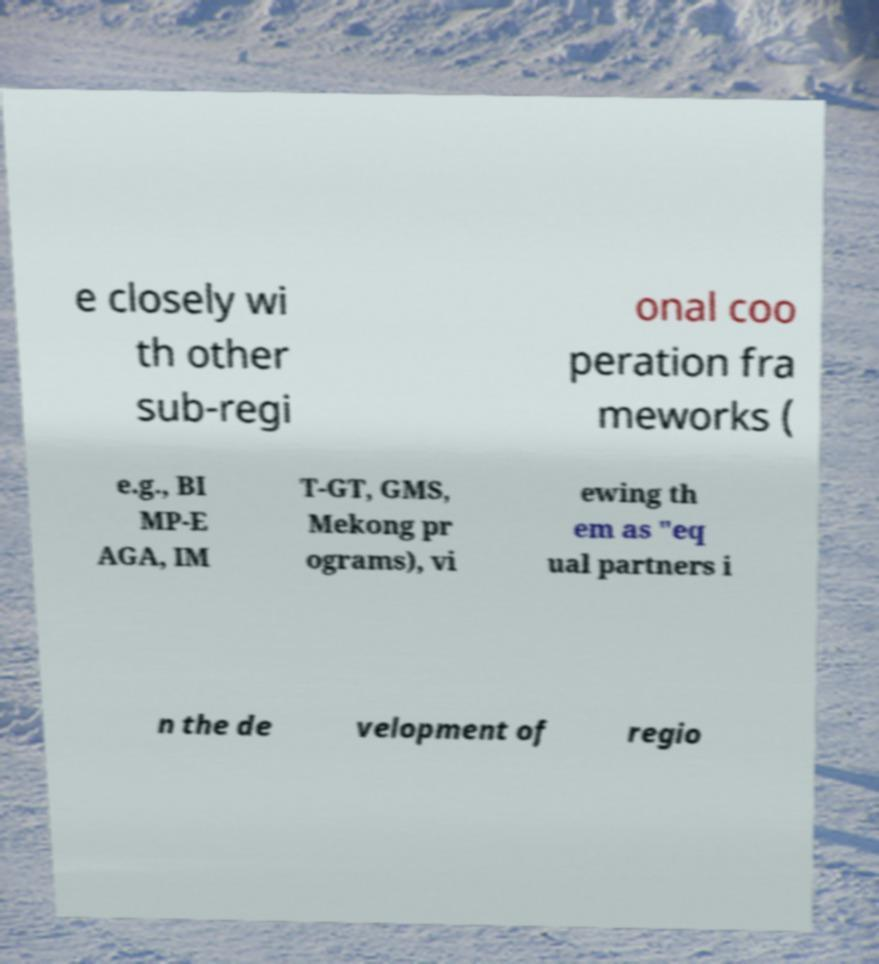For documentation purposes, I need the text within this image transcribed. Could you provide that? e closely wi th other sub-regi onal coo peration fra meworks ( e.g., BI MP-E AGA, IM T-GT, GMS, Mekong pr ograms), vi ewing th em as "eq ual partners i n the de velopment of regio 